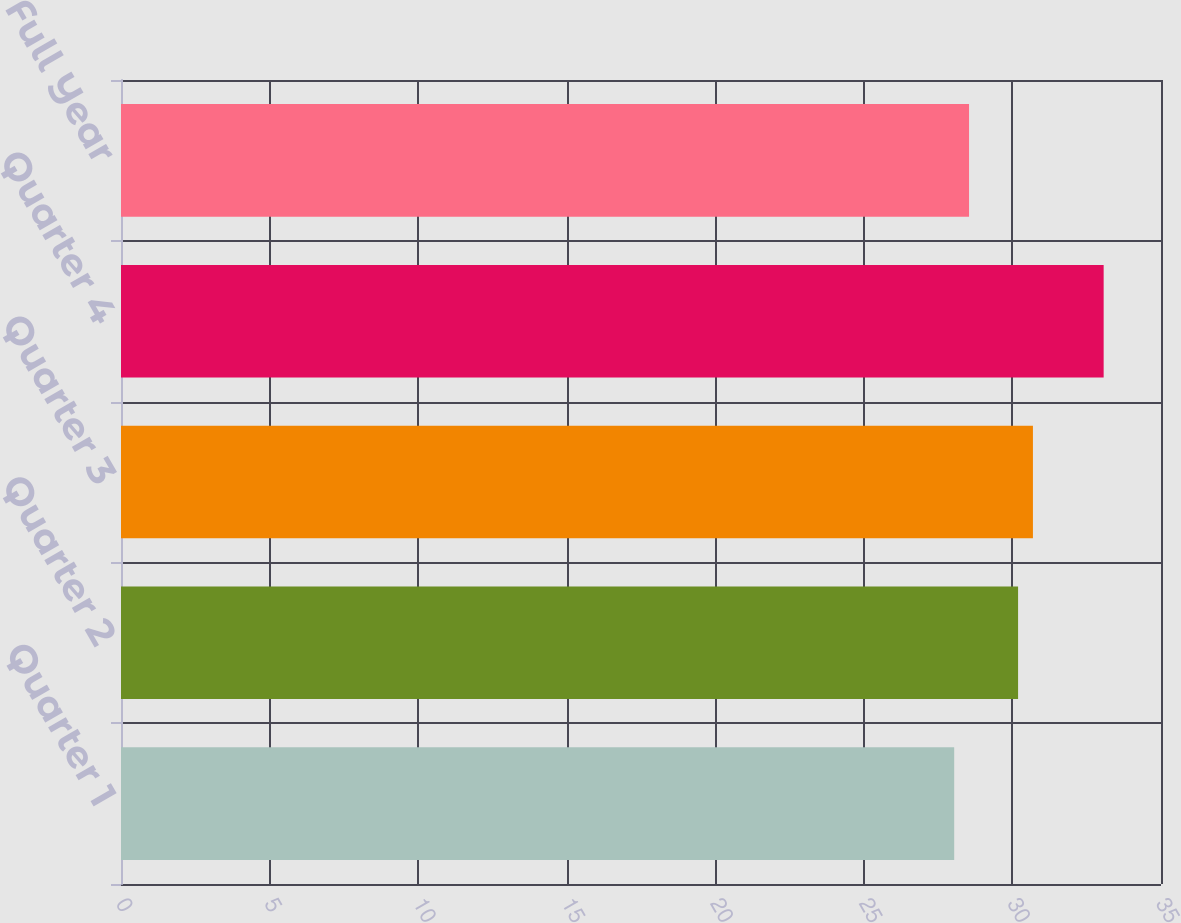Convert chart. <chart><loc_0><loc_0><loc_500><loc_500><bar_chart><fcel>Quarter 1<fcel>Quarter 2<fcel>Quarter 3<fcel>Quarter 4<fcel>Full Year<nl><fcel>28.04<fcel>30.19<fcel>30.69<fcel>33.07<fcel>28.54<nl></chart> 